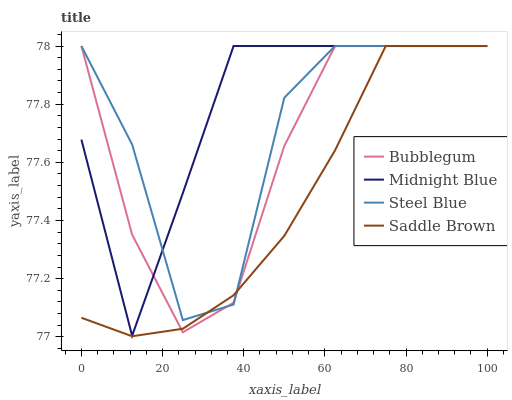Does Saddle Brown have the minimum area under the curve?
Answer yes or no. Yes. Does Midnight Blue have the maximum area under the curve?
Answer yes or no. Yes. Does Bubblegum have the minimum area under the curve?
Answer yes or no. No. Does Bubblegum have the maximum area under the curve?
Answer yes or no. No. Is Saddle Brown the smoothest?
Answer yes or no. Yes. Is Steel Blue the roughest?
Answer yes or no. Yes. Is Midnight Blue the smoothest?
Answer yes or no. No. Is Midnight Blue the roughest?
Answer yes or no. No. Does Saddle Brown have the lowest value?
Answer yes or no. Yes. Does Midnight Blue have the lowest value?
Answer yes or no. No. Does Steel Blue have the highest value?
Answer yes or no. Yes. Does Steel Blue intersect Bubblegum?
Answer yes or no. Yes. Is Steel Blue less than Bubblegum?
Answer yes or no. No. Is Steel Blue greater than Bubblegum?
Answer yes or no. No. 